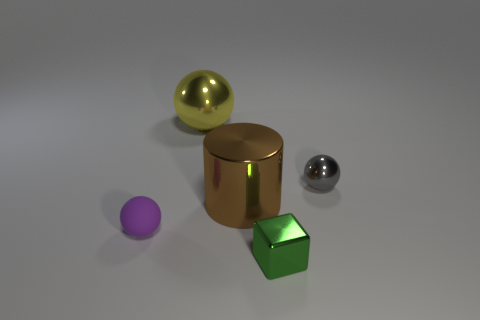Is the number of spheres in front of the small gray ball the same as the number of brown metallic cylinders?
Provide a short and direct response. Yes. Is the shape of the matte object the same as the tiny green metallic object?
Offer a very short reply. No. Are there any other things that are the same color as the tiny cube?
Your response must be concise. No. There is a object that is in front of the brown metallic thing and left of the green cube; what is its shape?
Your response must be concise. Sphere. Are there the same number of green metallic blocks to the left of the tiny green block and brown metal cylinders right of the big metallic cylinder?
Offer a terse response. Yes. How many cubes are small green objects or large metal objects?
Offer a very short reply. 1. What number of small green objects have the same material as the purple ball?
Provide a succinct answer. 0. What is the sphere that is both in front of the large metallic ball and behind the purple rubber sphere made of?
Provide a succinct answer. Metal. The shiny object in front of the big brown cylinder has what shape?
Ensure brevity in your answer.  Cube. What is the shape of the thing that is behind the object on the right side of the small green thing?
Offer a terse response. Sphere. 